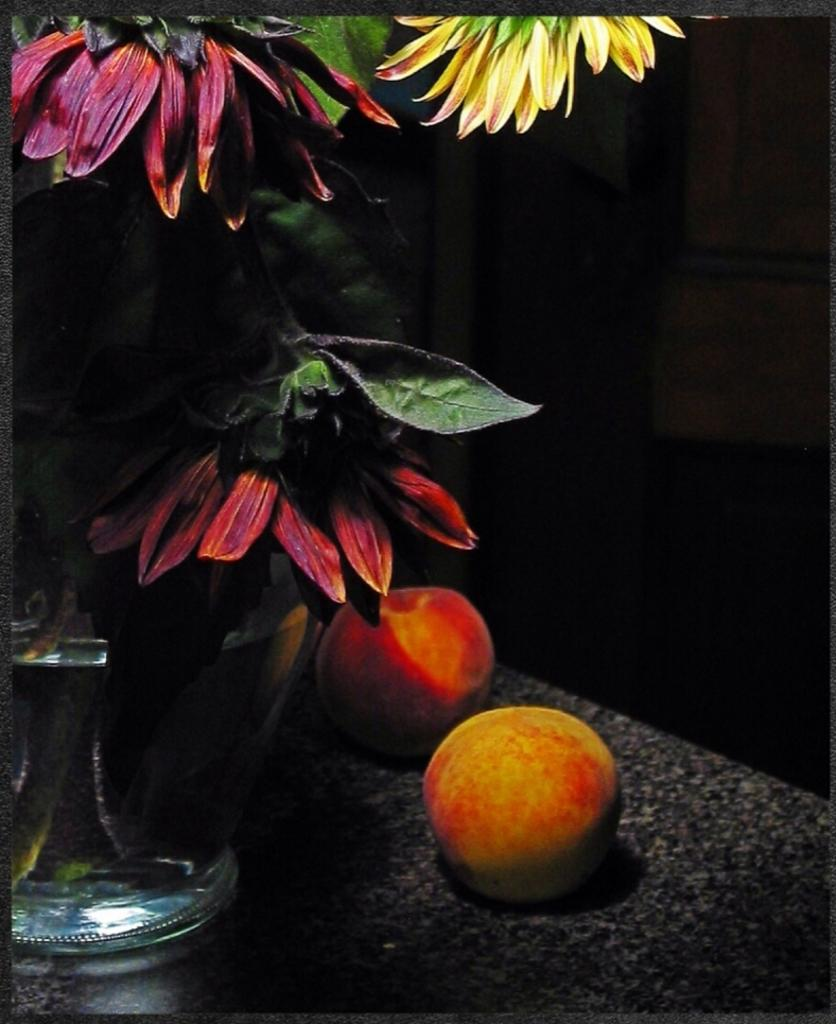What object is present on the left side of the image? There is a pot in the image. What is inside the pot? There is a plant in the image. Where are the pot and plant located in the image? The pot and plant are on the left side of the image. What can be seen in the front of the image? There are two fruits in the front of the image. How would you describe the background of the image? The background of the image is dark. What type of store is depicted in the image? There is no store present in the image; it features a pot, plant, and fruits. What committee is responsible for the arrangement of the fruits in the image? There is no committee involved in the arrangement of the fruits in the image; they are simply placed in the front. 